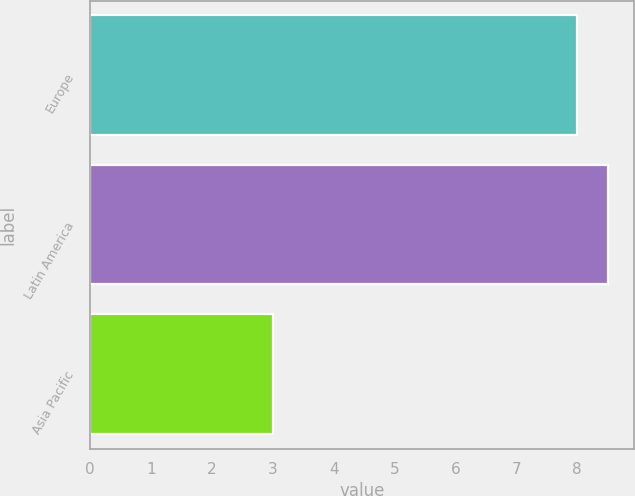Convert chart to OTSL. <chart><loc_0><loc_0><loc_500><loc_500><bar_chart><fcel>Europe<fcel>Latin America<fcel>Asia Pacific<nl><fcel>8<fcel>8.5<fcel>3<nl></chart> 